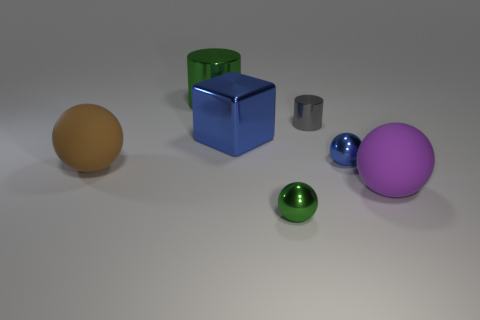Subtract all green shiny balls. How many balls are left? 3 Add 2 big green cylinders. How many objects exist? 9 Subtract 2 spheres. How many spheres are left? 2 Subtract all brown spheres. How many spheres are left? 3 Subtract all cylinders. How many objects are left? 5 Add 1 tiny balls. How many tiny balls are left? 3 Add 2 tiny matte cylinders. How many tiny matte cylinders exist? 2 Subtract 0 purple cubes. How many objects are left? 7 Subtract all cyan spheres. Subtract all green cubes. How many spheres are left? 4 Subtract all big balls. Subtract all green balls. How many objects are left? 4 